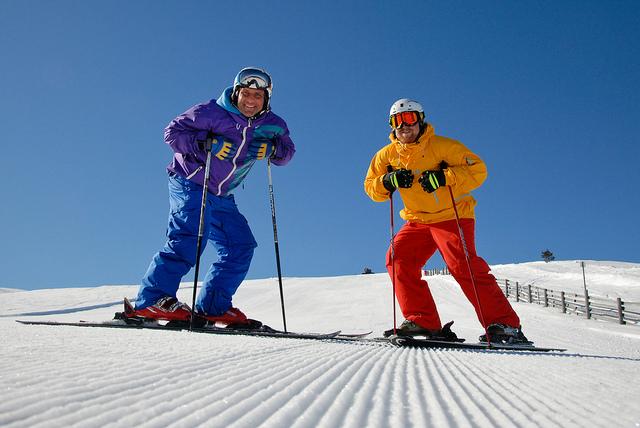Are the skiers wearing goggles?
Be succinct. Yes. Do they both have goggles?
Short answer required. Yes. What are the doing?
Give a very brief answer. Skiing. 